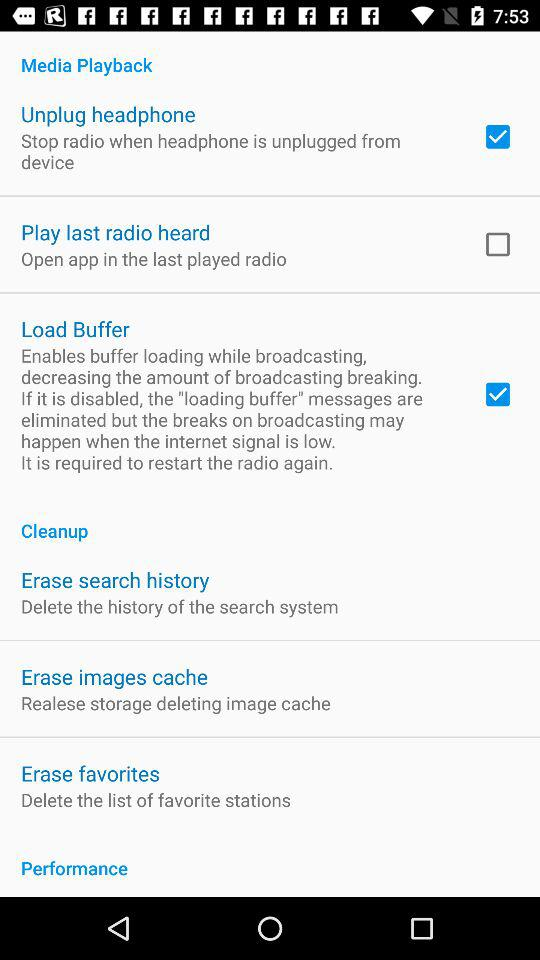Is "Load Buffer" enabled or disabled? The "Load Buffer" is enabled. 